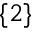Convert formula to latex. <formula><loc_0><loc_0><loc_500><loc_500>\{ 2 \}</formula> 